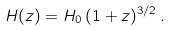<formula> <loc_0><loc_0><loc_500><loc_500>H ( z ) = H _ { 0 } \, ( 1 + z ) ^ { 3 / 2 } \, .</formula> 